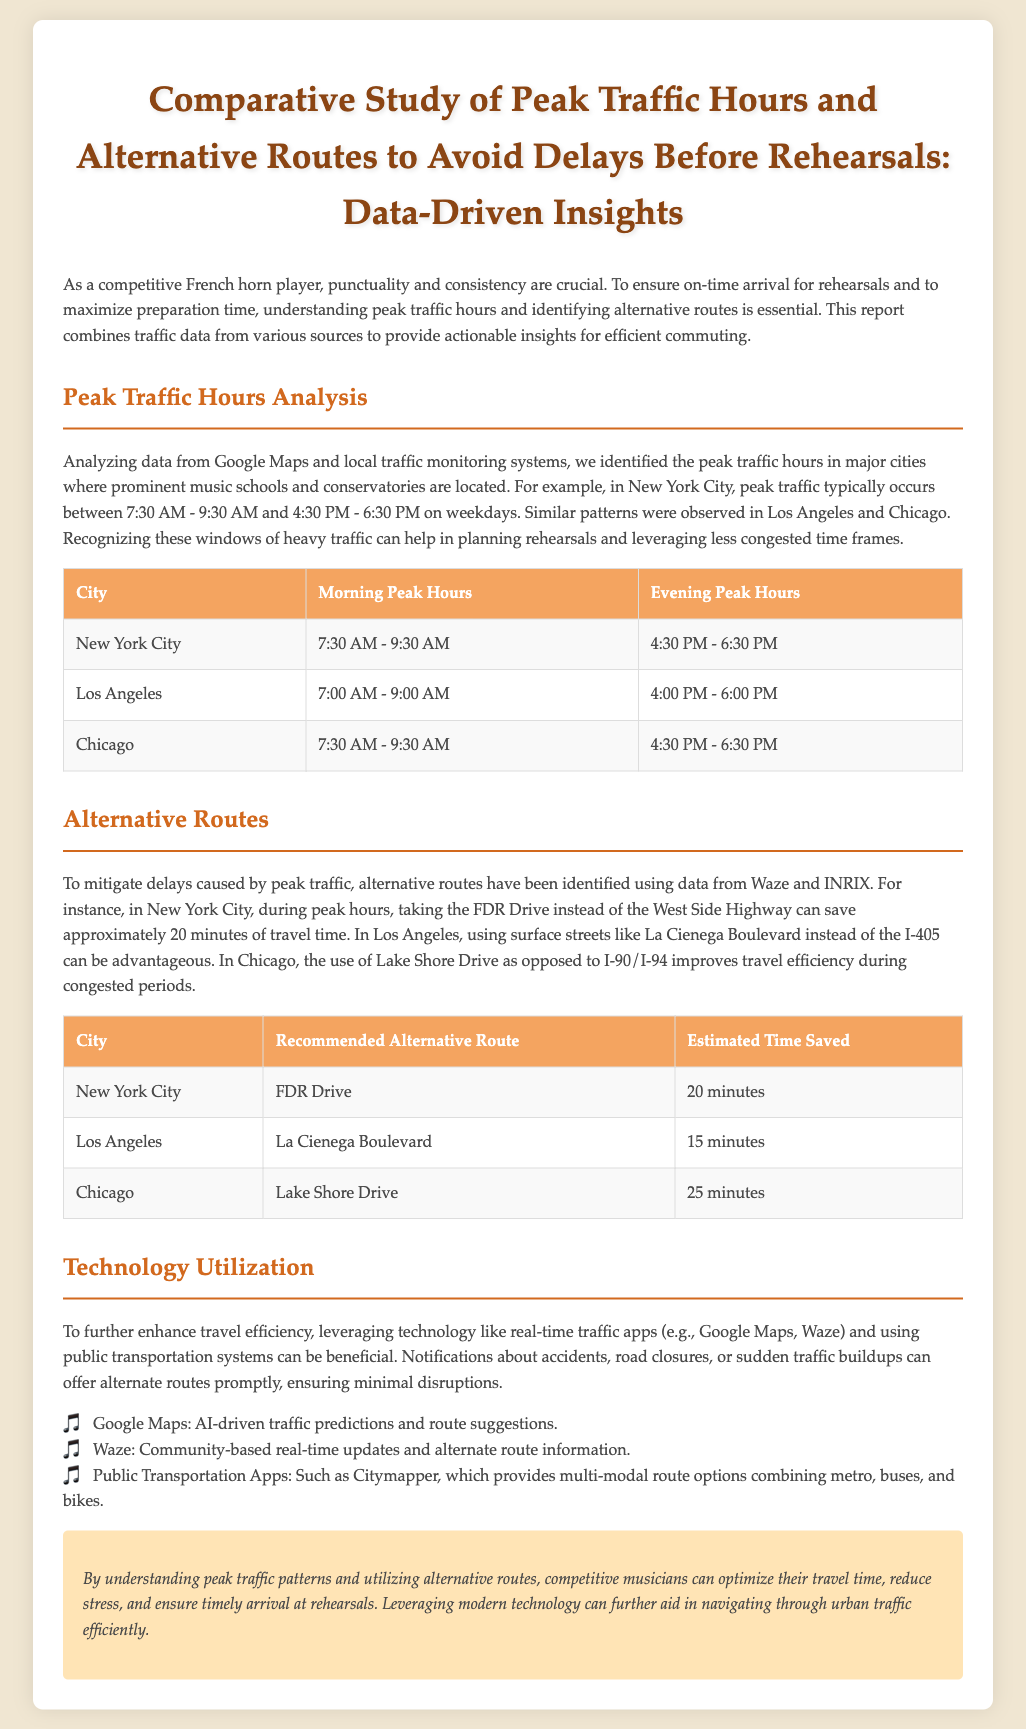What are the morning peak hours in New York City? The document specifies the morning peak hours for New York City as 7:30 AM - 9:30 AM.
Answer: 7:30 AM - 9:30 AM Which alternative route is recommended in Los Angeles? According to the report, the recommended alternative route in Los Angeles is La Cienega Boulevard.
Answer: La Cienega Boulevard How many minutes can be saved using the FDR Drive in New York City? The document states that using FDR Drive can save approximately 20 minutes of travel time in New York City.
Answer: 20 minutes What are the evening peak hours in Chicago? The specified evening peak hours in Chicago are from 4:30 PM to 6:30 PM.
Answer: 4:30 PM - 6:30 PM Which real-time traffic app is mentioned for community-based updates? The report mentions Waze as the community-based real-time updates app.
Answer: Waze What technology is recommended for enhancing travel efficiency? The document suggests leveraging technology like real-time traffic apps for enhancing travel efficiency.
Answer: Real-time traffic apps How much time can be saved using Lake Shore Drive in Chicago? The report indicates that using Lake Shore Drive can save 25 minutes of travel time in Chicago.
Answer: 25 minutes Why is understanding peak traffic patterns important for musicians? The document emphasizes that understanding peak traffic patterns is crucial for optimizing travel time and ensuring timely arrival at rehearsals.
Answer: Optimizing travel time and ensuring timely arrival 